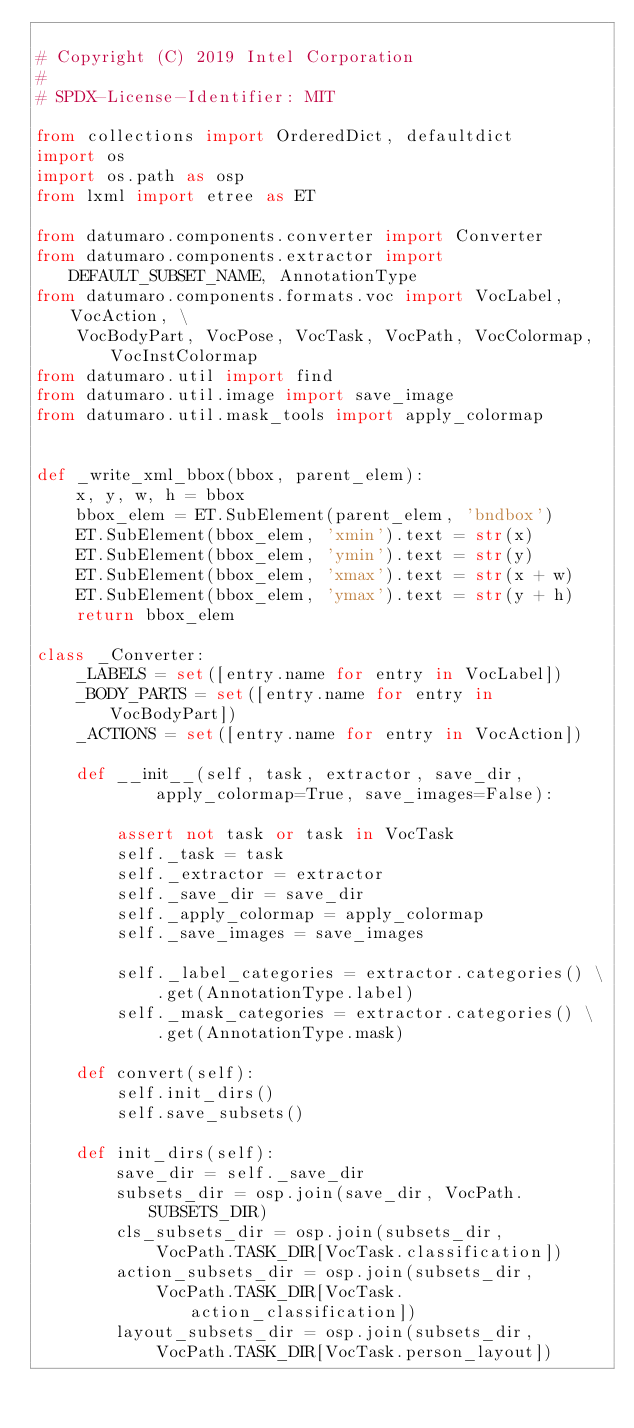<code> <loc_0><loc_0><loc_500><loc_500><_Python_>
# Copyright (C) 2019 Intel Corporation
#
# SPDX-License-Identifier: MIT

from collections import OrderedDict, defaultdict
import os
import os.path as osp
from lxml import etree as ET

from datumaro.components.converter import Converter
from datumaro.components.extractor import DEFAULT_SUBSET_NAME, AnnotationType
from datumaro.components.formats.voc import VocLabel, VocAction, \
    VocBodyPart, VocPose, VocTask, VocPath, VocColormap, VocInstColormap
from datumaro.util import find
from datumaro.util.image import save_image
from datumaro.util.mask_tools import apply_colormap


def _write_xml_bbox(bbox, parent_elem):
    x, y, w, h = bbox
    bbox_elem = ET.SubElement(parent_elem, 'bndbox')
    ET.SubElement(bbox_elem, 'xmin').text = str(x)
    ET.SubElement(bbox_elem, 'ymin').text = str(y)
    ET.SubElement(bbox_elem, 'xmax').text = str(x + w)
    ET.SubElement(bbox_elem, 'ymax').text = str(y + h)
    return bbox_elem

class _Converter:
    _LABELS = set([entry.name for entry in VocLabel])
    _BODY_PARTS = set([entry.name for entry in VocBodyPart])
    _ACTIONS = set([entry.name for entry in VocAction])

    def __init__(self, task, extractor, save_dir,
            apply_colormap=True, save_images=False):

        assert not task or task in VocTask
        self._task = task
        self._extractor = extractor
        self._save_dir = save_dir
        self._apply_colormap = apply_colormap
        self._save_images = save_images

        self._label_categories = extractor.categories() \
            .get(AnnotationType.label)
        self._mask_categories = extractor.categories() \
            .get(AnnotationType.mask)

    def convert(self):
        self.init_dirs()
        self.save_subsets()

    def init_dirs(self):
        save_dir = self._save_dir
        subsets_dir = osp.join(save_dir, VocPath.SUBSETS_DIR)
        cls_subsets_dir = osp.join(subsets_dir,
            VocPath.TASK_DIR[VocTask.classification])
        action_subsets_dir = osp.join(subsets_dir,
            VocPath.TASK_DIR[VocTask.action_classification])
        layout_subsets_dir = osp.join(subsets_dir,
            VocPath.TASK_DIR[VocTask.person_layout])</code> 